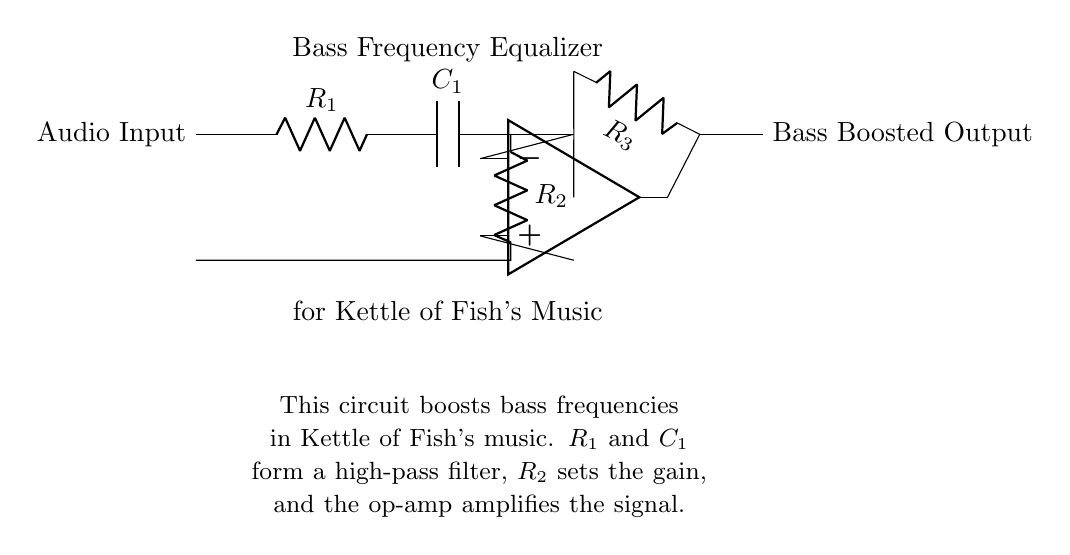What type of filter is used in this circuit? The circuit uses a high-pass filter, which is indicated by the capacitor and resistor connected in series. This configuration allows high-frequency signals to pass while attenuating low-frequency signals.
Answer: High-pass filter What is the function of the op-amp in this circuit? The op-amp in this circuit amplifies the signal, enhancing specific frequencies. It takes the output from the high-pass filter and increases its amplitude to boost the bass frequencies further.
Answer: Amplification How many resistors are present in the circuit? By examining the diagram, we can identify three resistors: R1, R2, and R3. Each plays a role in the filtering and gain configurations of the circuit.
Answer: Three What is the purpose of the capacitor in the high-pass filter? The capacitor blocks low-frequency signals, working with the resistor to establish the cutoff frequency for the high-pass filter. This ensures that only frequencies above the cutoff point contribute to the output signal.
Answer: Block low frequencies What is indicated by the label "Bass Frequency Equalizer"? This label suggests that the circuit is specifically designed to enhance the bass frequencies of audio signals, catering to the preferences of fans who enjoy the deep sounds typical in Kettle of Fish's music.
Answer: Bass enhancement 